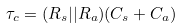Convert formula to latex. <formula><loc_0><loc_0><loc_500><loc_500>\tau _ { c } = ( R _ { s } | | R _ { a } ) ( C _ { s } + C _ { a } )</formula> 